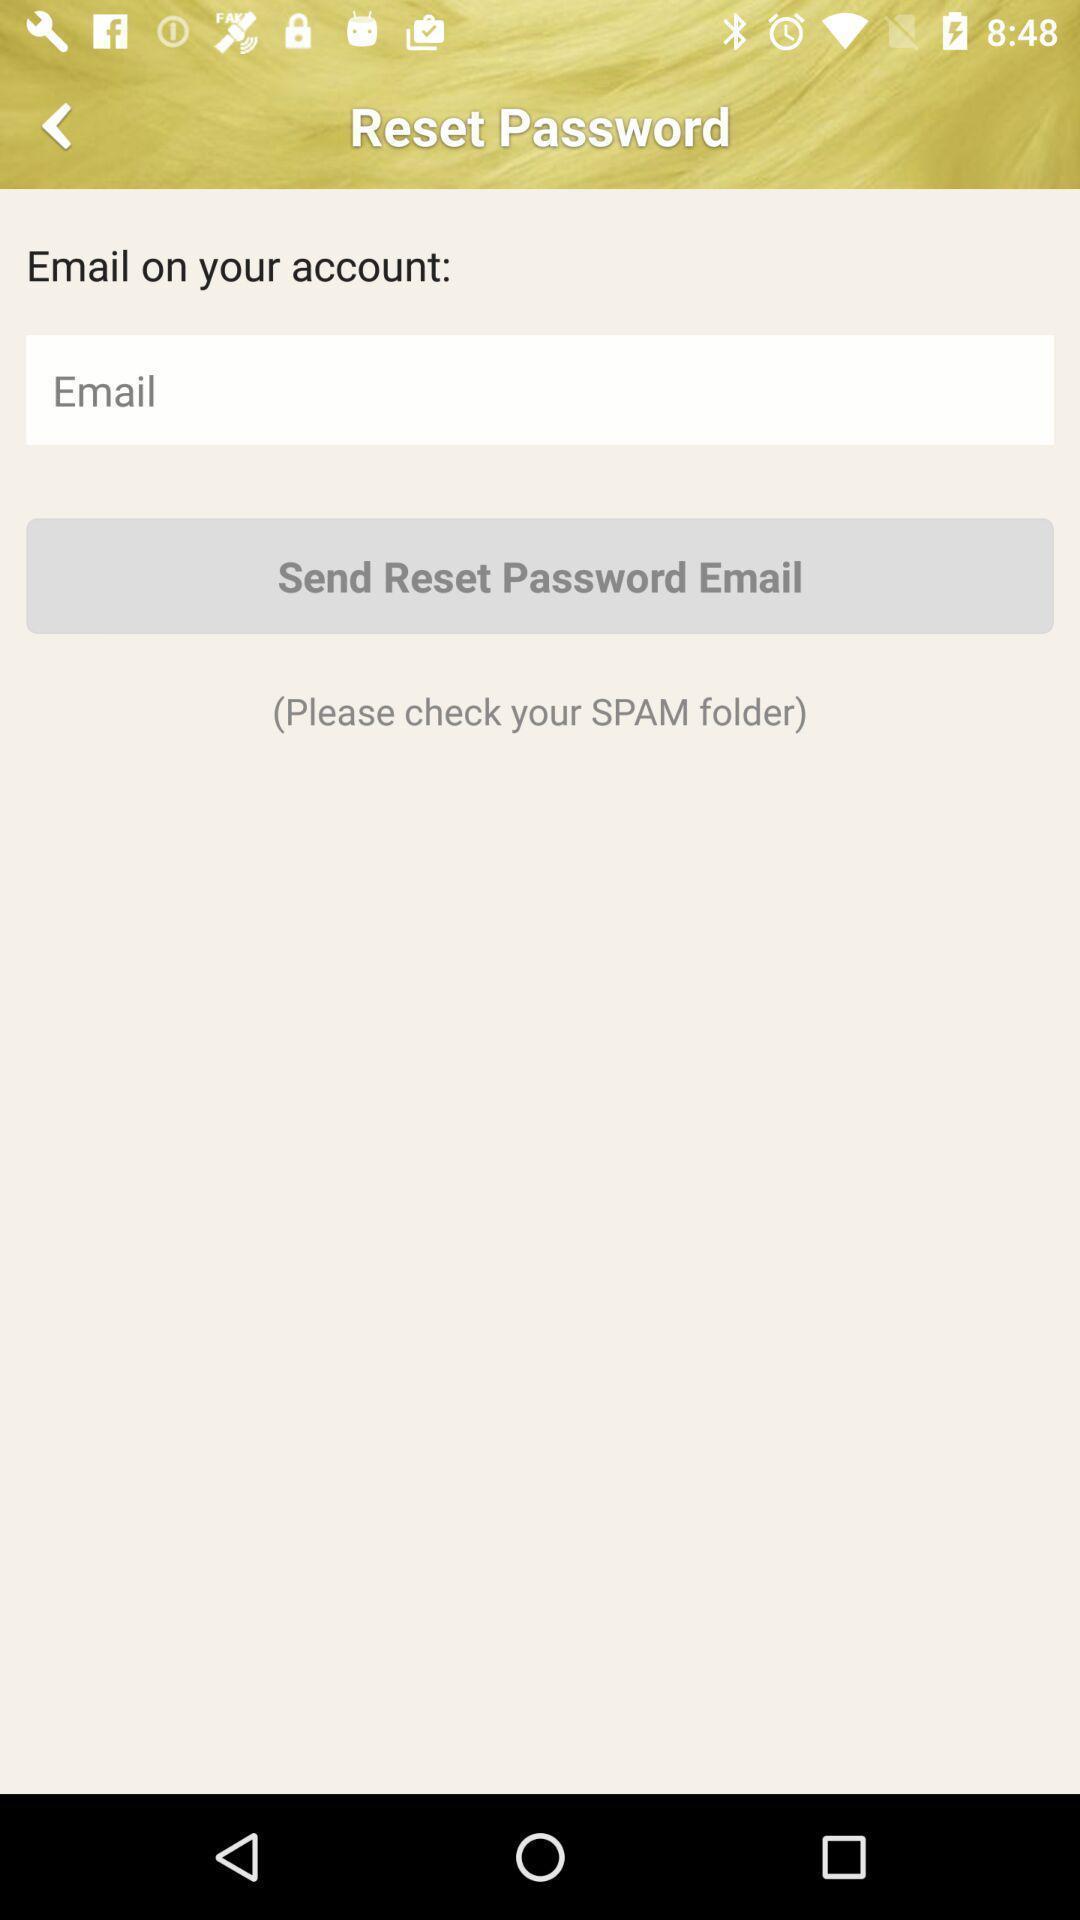What can you discern from this picture? Page displays reset password option for an application. 